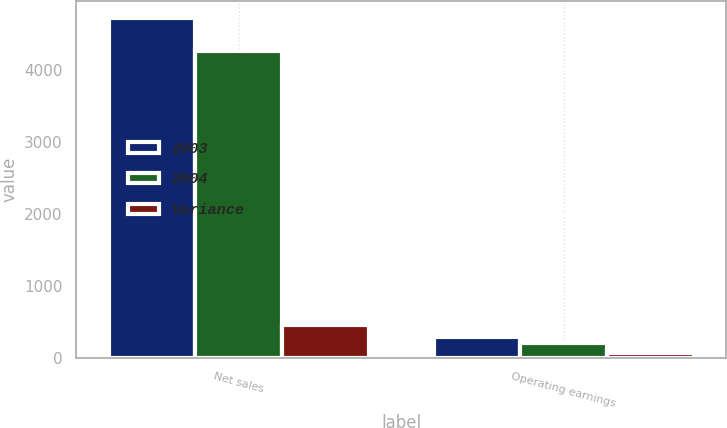Convert chart to OTSL. <chart><loc_0><loc_0><loc_500><loc_500><stacked_bar_chart><ecel><fcel>Net sales<fcel>Operating earnings<nl><fcel>2003<fcel>4726<fcel>292<nl><fcel>2004<fcel>4271<fcel>216<nl><fcel>Variance<fcel>455<fcel>76<nl></chart> 